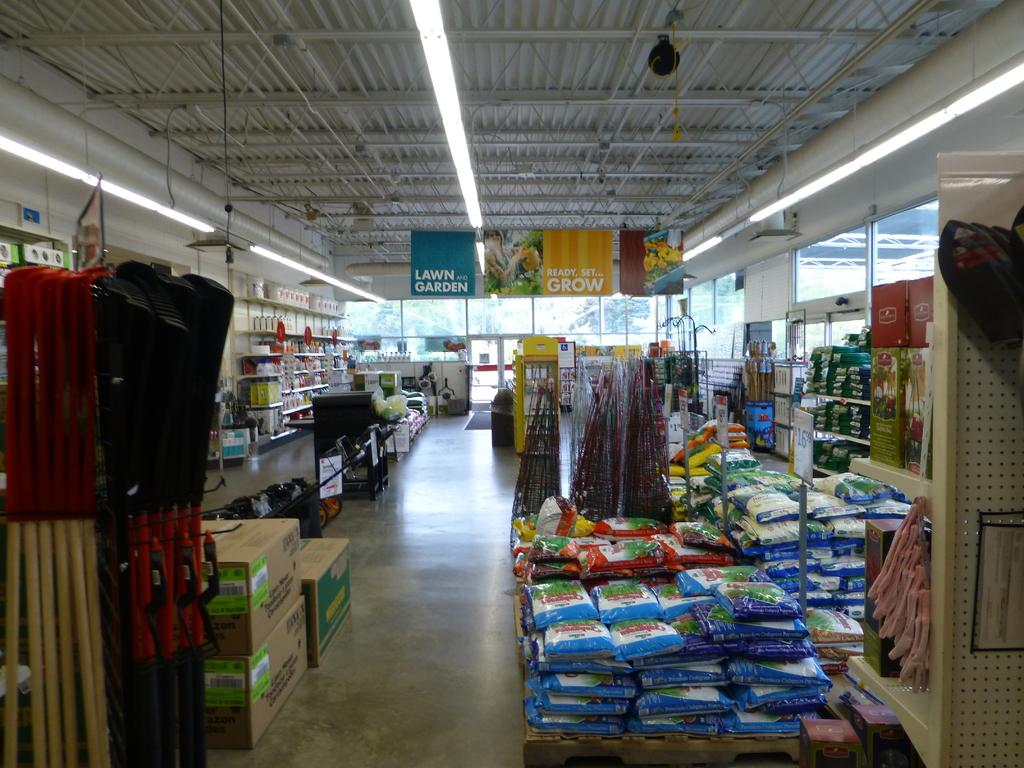What section of the store is the picture taken in?
Offer a terse response. Lawn and garden. What does the yellow section of the sign say?
Give a very brief answer. Ready set grow. 